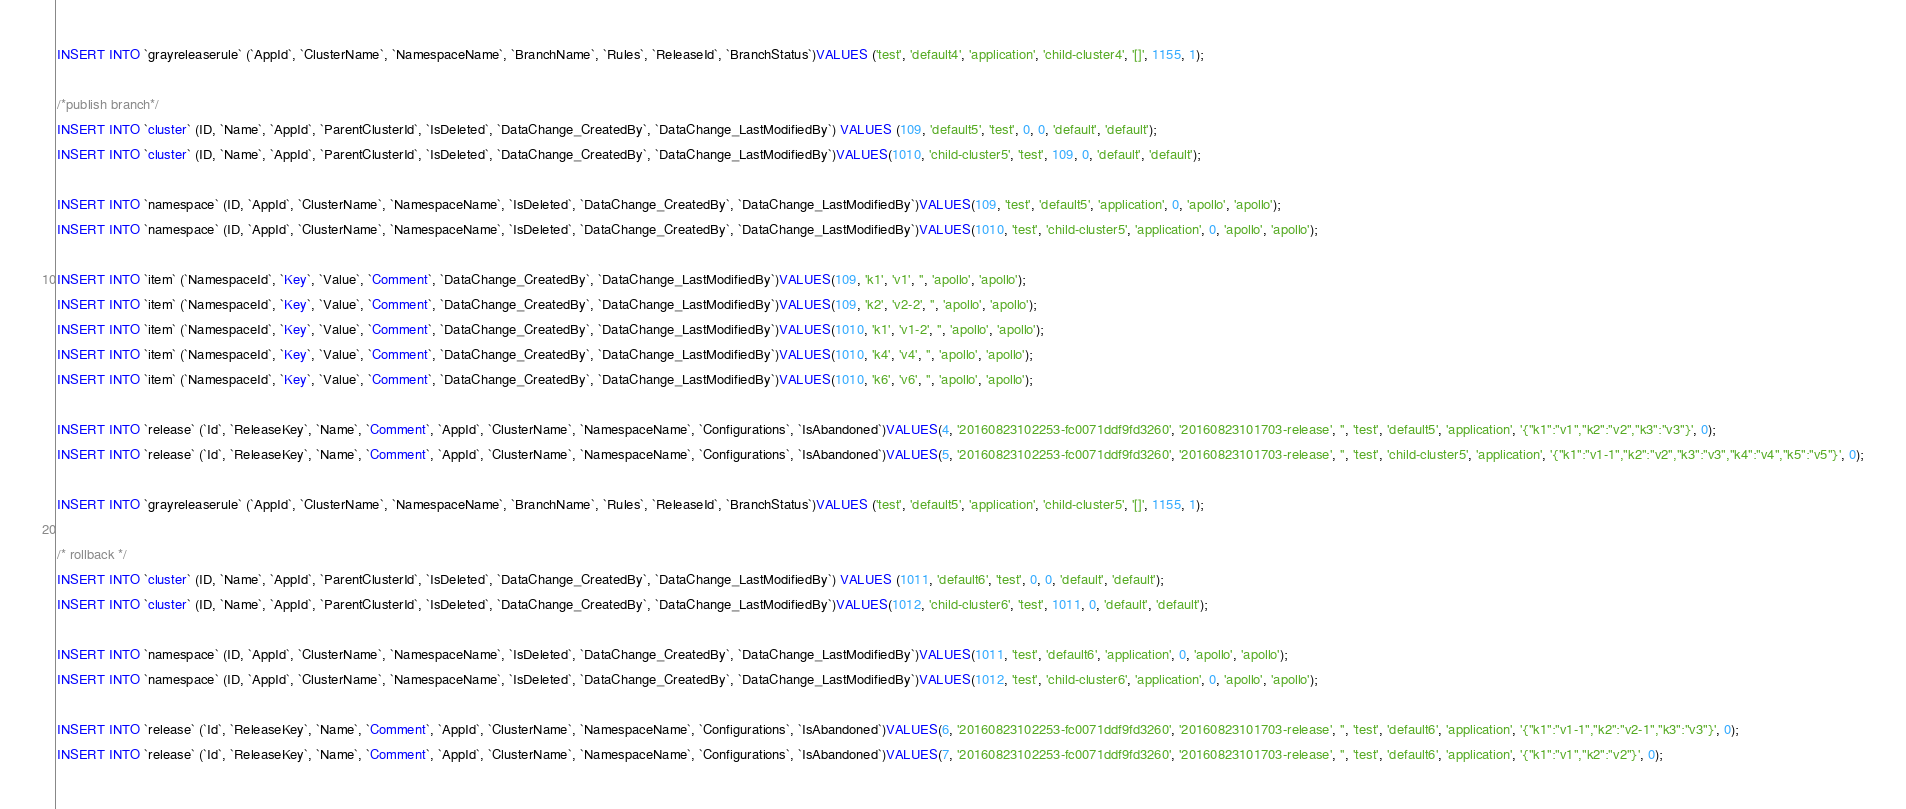Convert code to text. <code><loc_0><loc_0><loc_500><loc_500><_SQL_>
INSERT INTO `grayreleaserule` (`AppId`, `ClusterName`, `NamespaceName`, `BranchName`, `Rules`, `ReleaseId`, `BranchStatus`)VALUES ('test', 'default4', 'application', 'child-cluster4', '[]', 1155, 1);

/*publish branch*/
INSERT INTO `cluster` (ID, `Name`, `AppId`, `ParentClusterId`, `IsDeleted`, `DataChange_CreatedBy`, `DataChange_LastModifiedBy`) VALUES (109, 'default5', 'test', 0, 0, 'default', 'default');
INSERT INTO `cluster` (ID, `Name`, `AppId`, `ParentClusterId`, `IsDeleted`, `DataChange_CreatedBy`, `DataChange_LastModifiedBy`)VALUES(1010, 'child-cluster5', 'test', 109, 0, 'default', 'default');

INSERT INTO `namespace` (ID, `AppId`, `ClusterName`, `NamespaceName`, `IsDeleted`, `DataChange_CreatedBy`, `DataChange_LastModifiedBy`)VALUES(109, 'test', 'default5', 'application', 0, 'apollo', 'apollo');
INSERT INTO `namespace` (ID, `AppId`, `ClusterName`, `NamespaceName`, `IsDeleted`, `DataChange_CreatedBy`, `DataChange_LastModifiedBy`)VALUES(1010, 'test', 'child-cluster5', 'application', 0, 'apollo', 'apollo');

INSERT INTO `item` (`NamespaceId`, `Key`, `Value`, `Comment`, `DataChange_CreatedBy`, `DataChange_LastModifiedBy`)VALUES(109, 'k1', 'v1', '', 'apollo', 'apollo');
INSERT INTO `item` (`NamespaceId`, `Key`, `Value`, `Comment`, `DataChange_CreatedBy`, `DataChange_LastModifiedBy`)VALUES(109, 'k2', 'v2-2', '', 'apollo', 'apollo');
INSERT INTO `item` (`NamespaceId`, `Key`, `Value`, `Comment`, `DataChange_CreatedBy`, `DataChange_LastModifiedBy`)VALUES(1010, 'k1', 'v1-2', '', 'apollo', 'apollo');
INSERT INTO `item` (`NamespaceId`, `Key`, `Value`, `Comment`, `DataChange_CreatedBy`, `DataChange_LastModifiedBy`)VALUES(1010, 'k4', 'v4', '', 'apollo', 'apollo');
INSERT INTO `item` (`NamespaceId`, `Key`, `Value`, `Comment`, `DataChange_CreatedBy`, `DataChange_LastModifiedBy`)VALUES(1010, 'k6', 'v6', '', 'apollo', 'apollo');

INSERT INTO `release` (`Id`, `ReleaseKey`, `Name`, `Comment`, `AppId`, `ClusterName`, `NamespaceName`, `Configurations`, `IsAbandoned`)VALUES(4, '20160823102253-fc0071ddf9fd3260', '20160823101703-release', '', 'test', 'default5', 'application', '{"k1":"v1","k2":"v2","k3":"v3"}', 0);
INSERT INTO `release` (`Id`, `ReleaseKey`, `Name`, `Comment`, `AppId`, `ClusterName`, `NamespaceName`, `Configurations`, `IsAbandoned`)VALUES(5, '20160823102253-fc0071ddf9fd3260', '20160823101703-release', '', 'test', 'child-cluster5', 'application', '{"k1":"v1-1","k2":"v2","k3":"v3","k4":"v4","k5":"v5"}', 0);

INSERT INTO `grayreleaserule` (`AppId`, `ClusterName`, `NamespaceName`, `BranchName`, `Rules`, `ReleaseId`, `BranchStatus`)VALUES ('test', 'default5', 'application', 'child-cluster5', '[]', 1155, 1);

/* rollback */
INSERT INTO `cluster` (ID, `Name`, `AppId`, `ParentClusterId`, `IsDeleted`, `DataChange_CreatedBy`, `DataChange_LastModifiedBy`) VALUES (1011, 'default6', 'test', 0, 0, 'default', 'default');
INSERT INTO `cluster` (ID, `Name`, `AppId`, `ParentClusterId`, `IsDeleted`, `DataChange_CreatedBy`, `DataChange_LastModifiedBy`)VALUES(1012, 'child-cluster6', 'test', 1011, 0, 'default', 'default');

INSERT INTO `namespace` (ID, `AppId`, `ClusterName`, `NamespaceName`, `IsDeleted`, `DataChange_CreatedBy`, `DataChange_LastModifiedBy`)VALUES(1011, 'test', 'default6', 'application', 0, 'apollo', 'apollo');
INSERT INTO `namespace` (ID, `AppId`, `ClusterName`, `NamespaceName`, `IsDeleted`, `DataChange_CreatedBy`, `DataChange_LastModifiedBy`)VALUES(1012, 'test', 'child-cluster6', 'application', 0, 'apollo', 'apollo');

INSERT INTO `release` (`Id`, `ReleaseKey`, `Name`, `Comment`, `AppId`, `ClusterName`, `NamespaceName`, `Configurations`, `IsAbandoned`)VALUES(6, '20160823102253-fc0071ddf9fd3260', '20160823101703-release', '', 'test', 'default6', 'application', '{"k1":"v1-1","k2":"v2-1","k3":"v3"}', 0);
INSERT INTO `release` (`Id`, `ReleaseKey`, `Name`, `Comment`, `AppId`, `ClusterName`, `NamespaceName`, `Configurations`, `IsAbandoned`)VALUES(7, '20160823102253-fc0071ddf9fd3260', '20160823101703-release', '', 'test', 'default6', 'application', '{"k1":"v1","k2":"v2"}', 0);</code> 